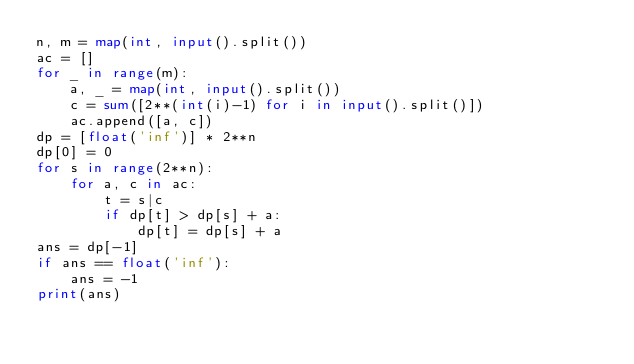Convert code to text. <code><loc_0><loc_0><loc_500><loc_500><_Python_>n, m = map(int, input().split())
ac = []
for _ in range(m):
    a, _ = map(int, input().split())
    c = sum([2**(int(i)-1) for i in input().split()])
    ac.append([a, c])
dp = [float('inf')] * 2**n
dp[0] = 0
for s in range(2**n):
    for a, c in ac:
        t = s|c
        if dp[t] > dp[s] + a:
            dp[t] = dp[s] + a
ans = dp[-1]
if ans == float('inf'):
    ans = -1
print(ans)</code> 